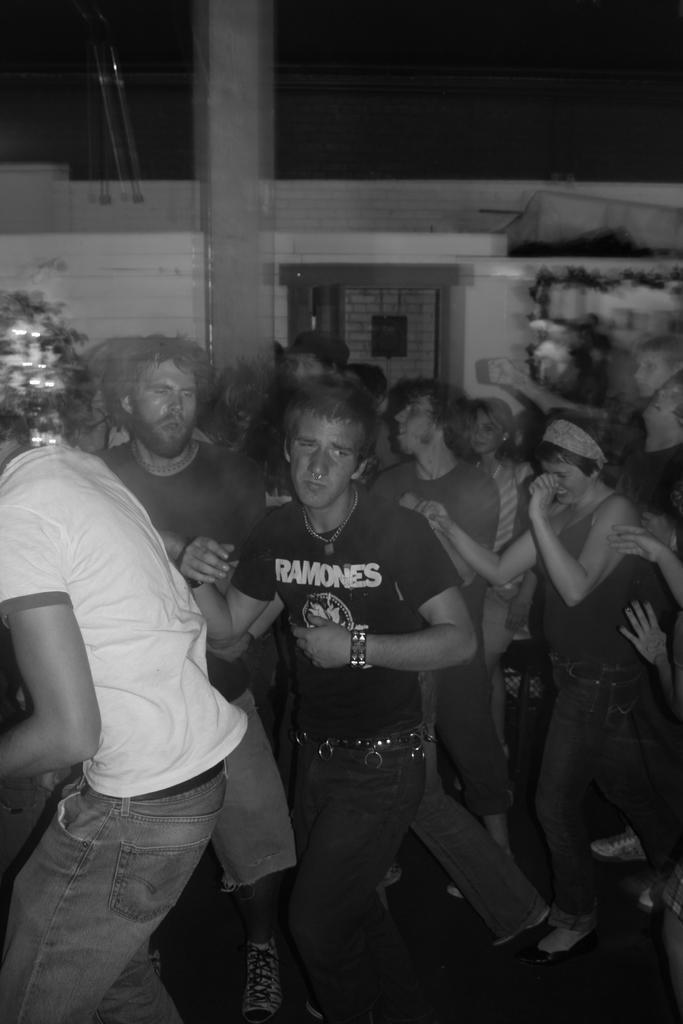How would you summarize this image in a sentence or two? This is the black and white picture of two men standing and dancing on the floor, in the back there is wall. 